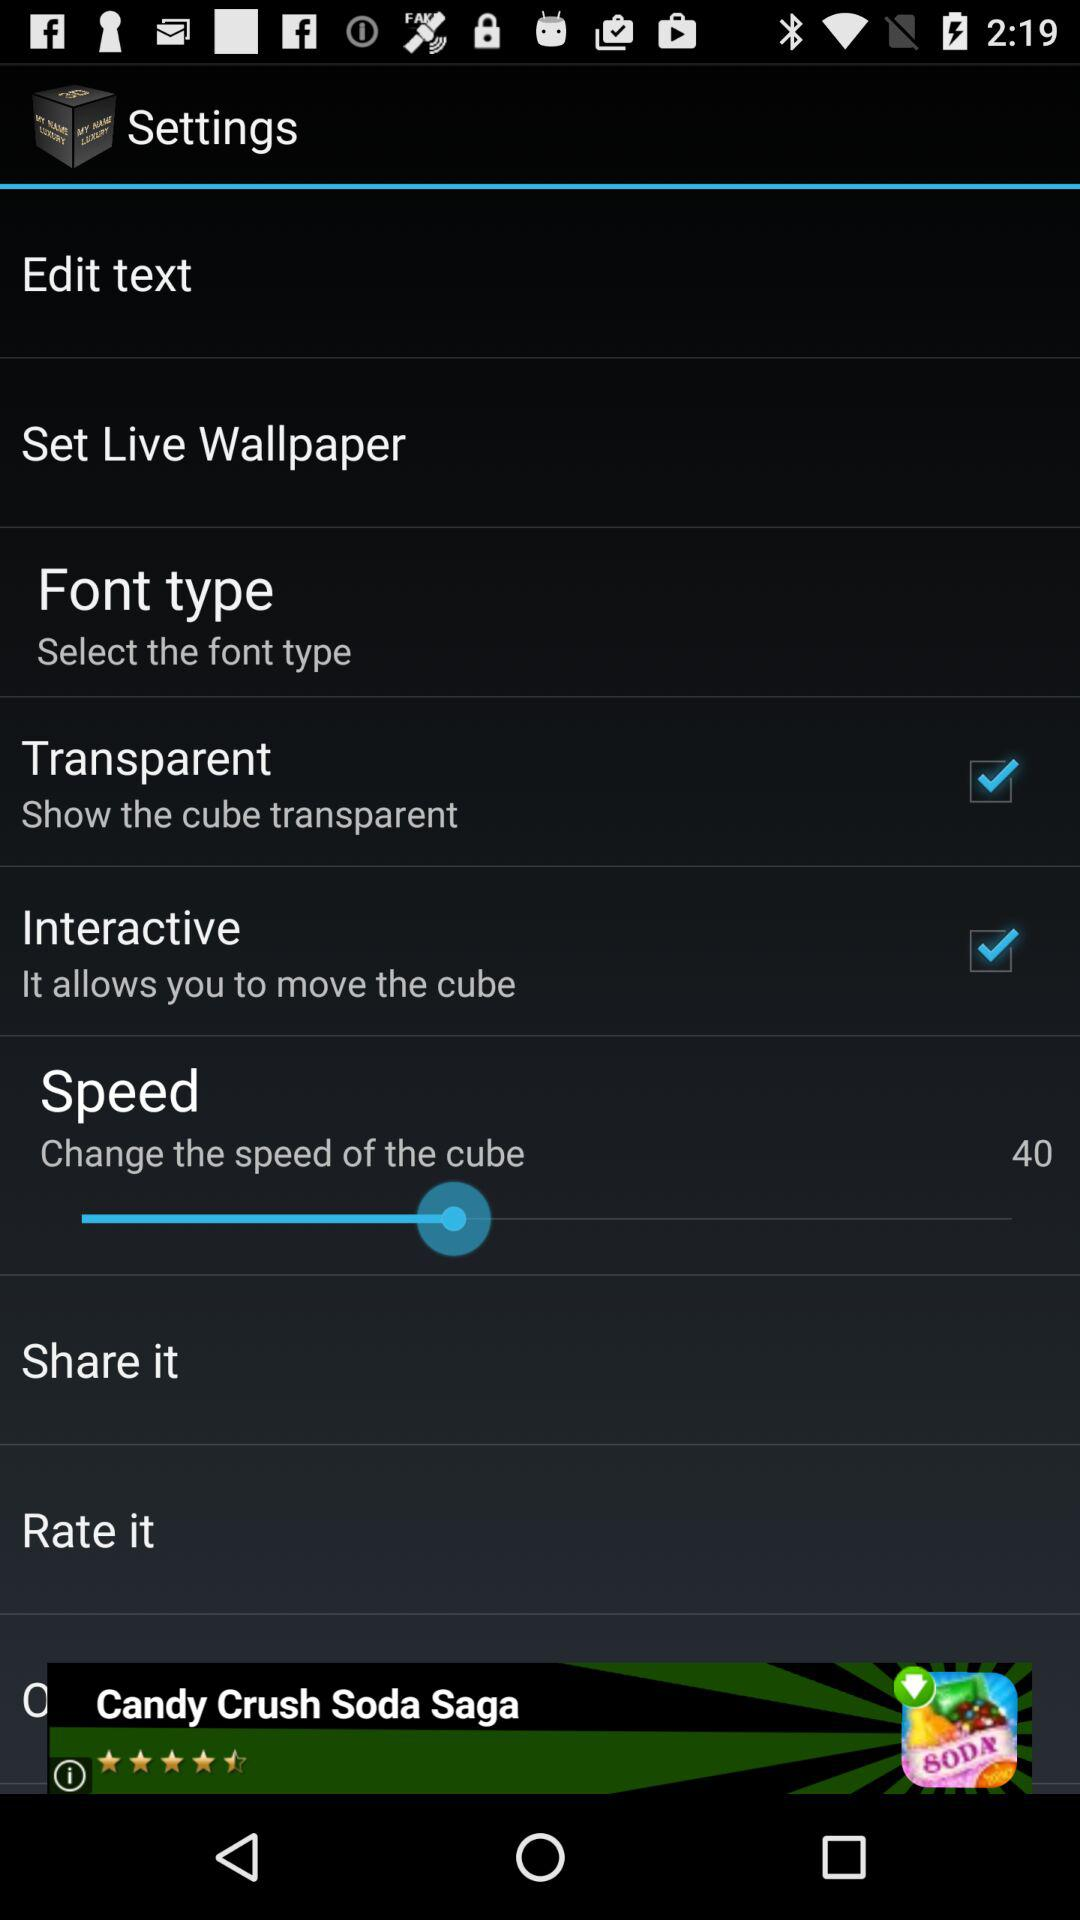What is the value of "Speed"? The value is 40. 